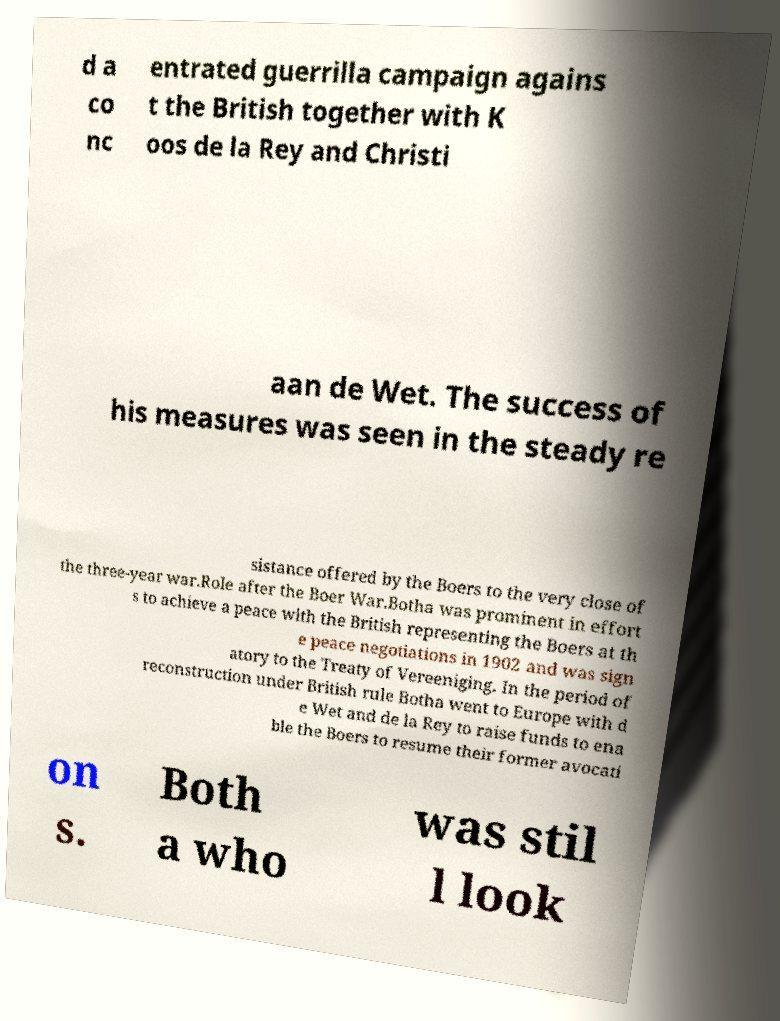Can you read and provide the text displayed in the image?This photo seems to have some interesting text. Can you extract and type it out for me? d a co nc entrated guerrilla campaign agains t the British together with K oos de la Rey and Christi aan de Wet. The success of his measures was seen in the steady re sistance offered by the Boers to the very close of the three-year war.Role after the Boer War.Botha was prominent in effort s to achieve a peace with the British representing the Boers at th e peace negotiations in 1902 and was sign atory to the Treaty of Vereeniging. In the period of reconstruction under British rule Botha went to Europe with d e Wet and de la Rey to raise funds to ena ble the Boers to resume their former avocati on s. Both a who was stil l look 